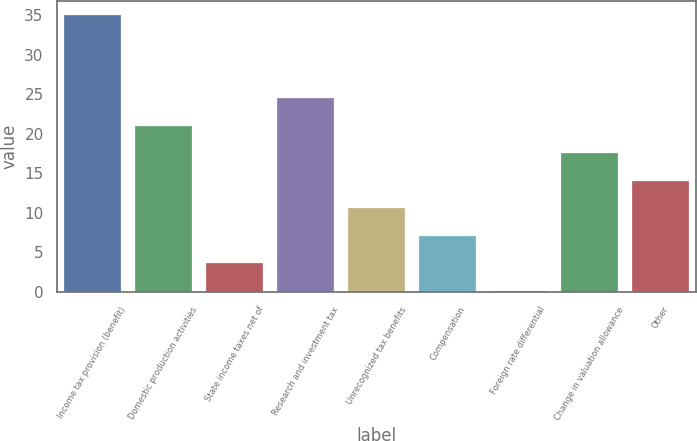Convert chart to OTSL. <chart><loc_0><loc_0><loc_500><loc_500><bar_chart><fcel>Income tax provision (benefit)<fcel>Domestic production activities<fcel>State income taxes net of<fcel>Research and investment tax<fcel>Unrecognized tax benefits<fcel>Compensation<fcel>Foreign rate differential<fcel>Change in valuation allowance<fcel>Other<nl><fcel>35<fcel>21.04<fcel>3.59<fcel>24.53<fcel>10.57<fcel>7.08<fcel>0.1<fcel>17.55<fcel>14.06<nl></chart> 